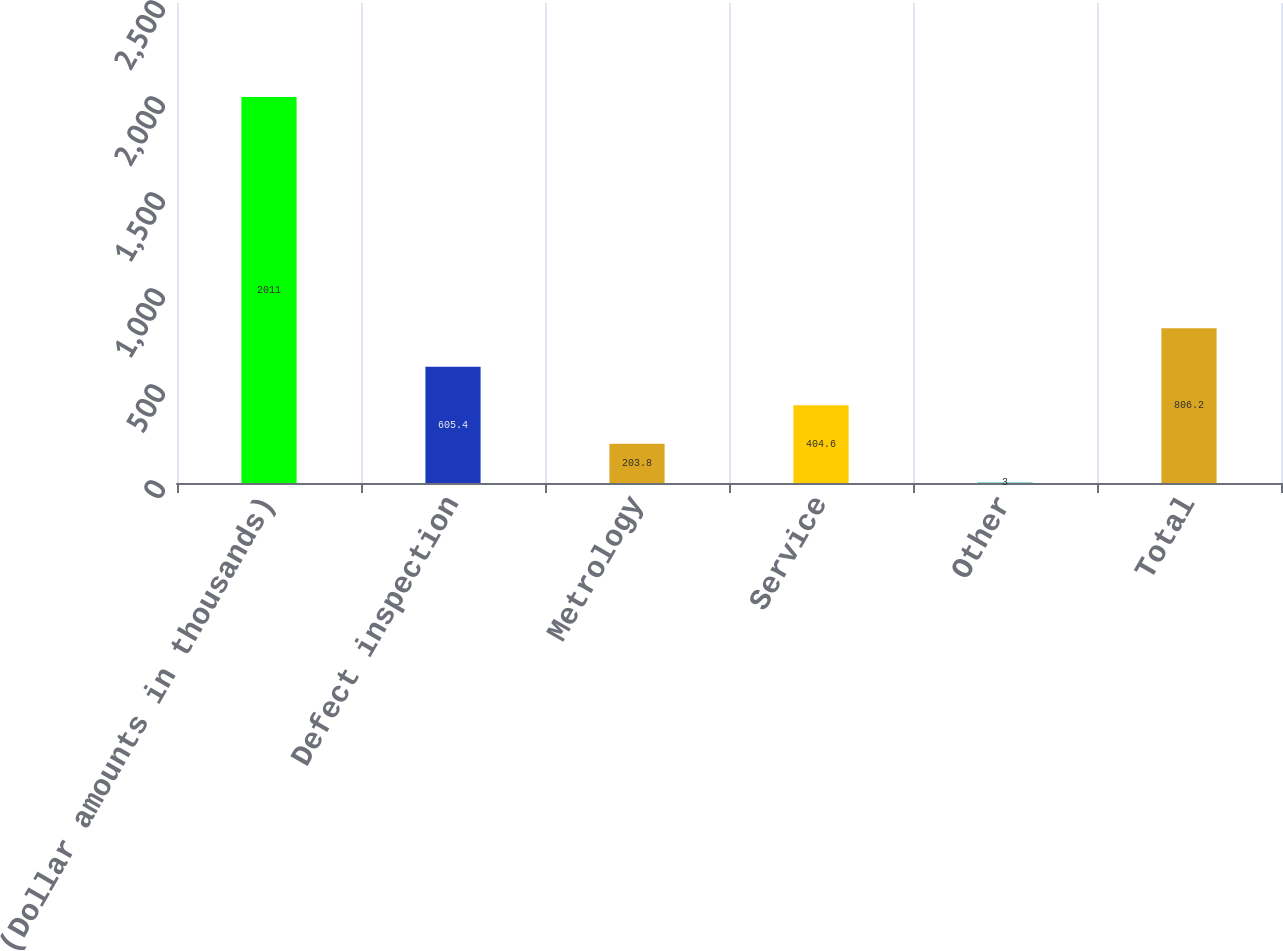Convert chart. <chart><loc_0><loc_0><loc_500><loc_500><bar_chart><fcel>(Dollar amounts in thousands)<fcel>Defect inspection<fcel>Metrology<fcel>Service<fcel>Other<fcel>Total<nl><fcel>2011<fcel>605.4<fcel>203.8<fcel>404.6<fcel>3<fcel>806.2<nl></chart> 